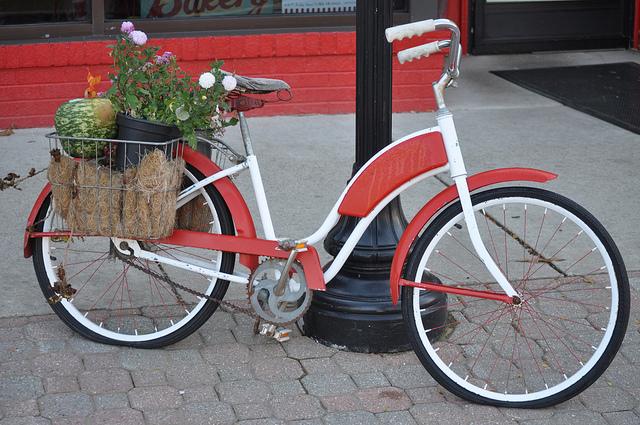How many bikes are here?
Write a very short answer. 1. What is the bike locked to?
Answer briefly. Pole. What color are the handlebars?
Keep it brief. White. What color is the bike?
Short answer required. Red. What is in his basket?
Give a very brief answer. Flowers. What is in the basket?
Short answer required. Flowers. How old is the bike?
Concise answer only. New. Is the red wall made of bricks?
Short answer required. Yes. What fruit is on the bicycle?
Short answer required. Watermelon. Is there a basket on the bike?
Be succinct. Yes. 